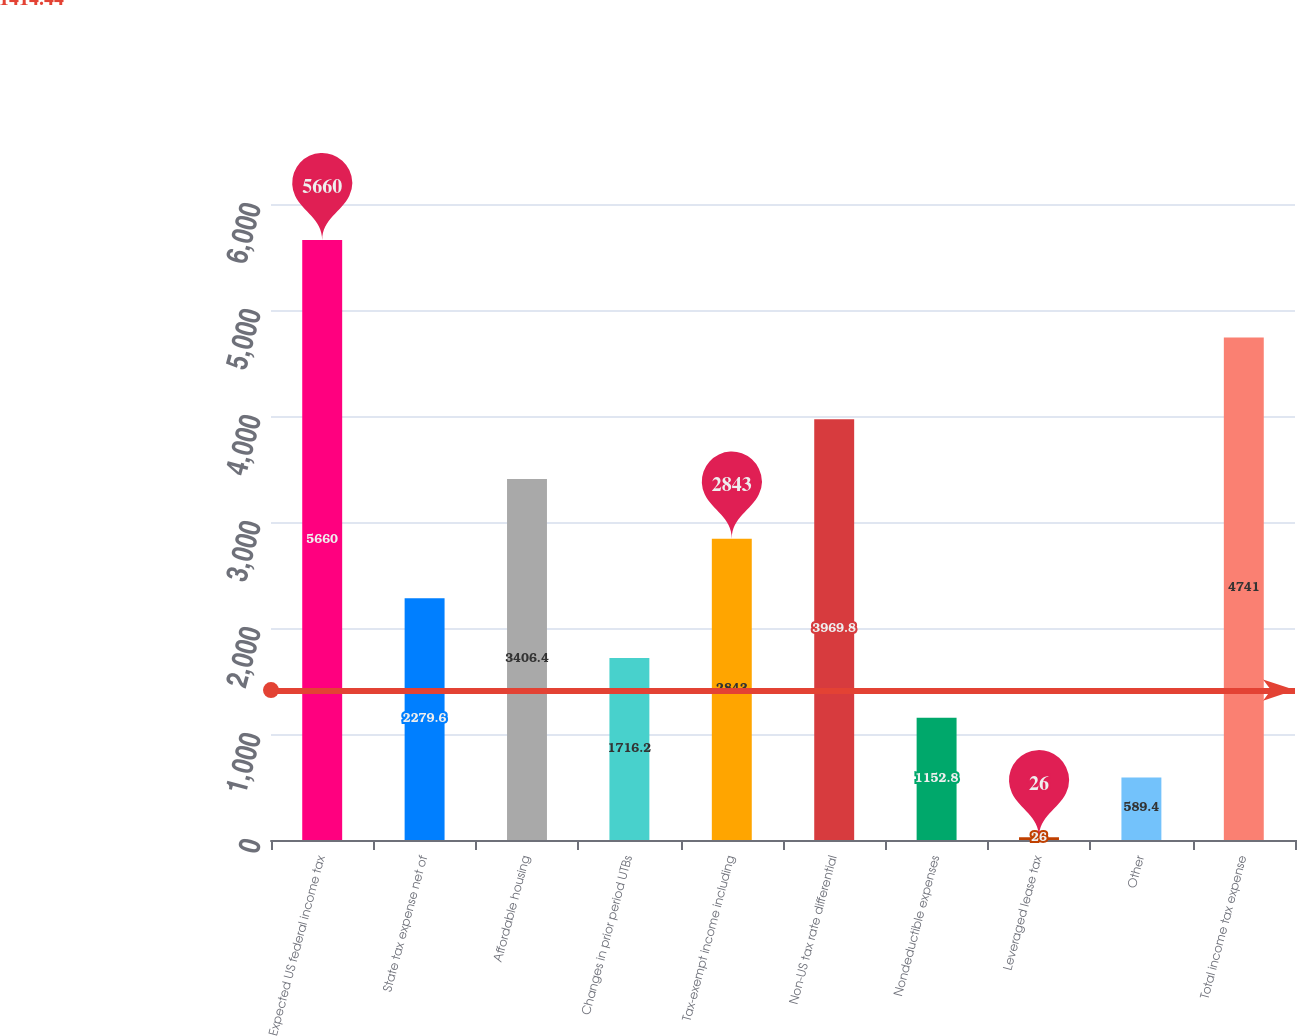Convert chart to OTSL. <chart><loc_0><loc_0><loc_500><loc_500><bar_chart><fcel>Expected US federal income tax<fcel>State tax expense net of<fcel>Affordable housing<fcel>Changes in prior period UTBs<fcel>Tax-exempt income including<fcel>Non-US tax rate differential<fcel>Nondeductible expenses<fcel>Leveraged lease tax<fcel>Other<fcel>Total income tax expense<nl><fcel>5660<fcel>2279.6<fcel>3406.4<fcel>1716.2<fcel>2843<fcel>3969.8<fcel>1152.8<fcel>26<fcel>589.4<fcel>4741<nl></chart> 